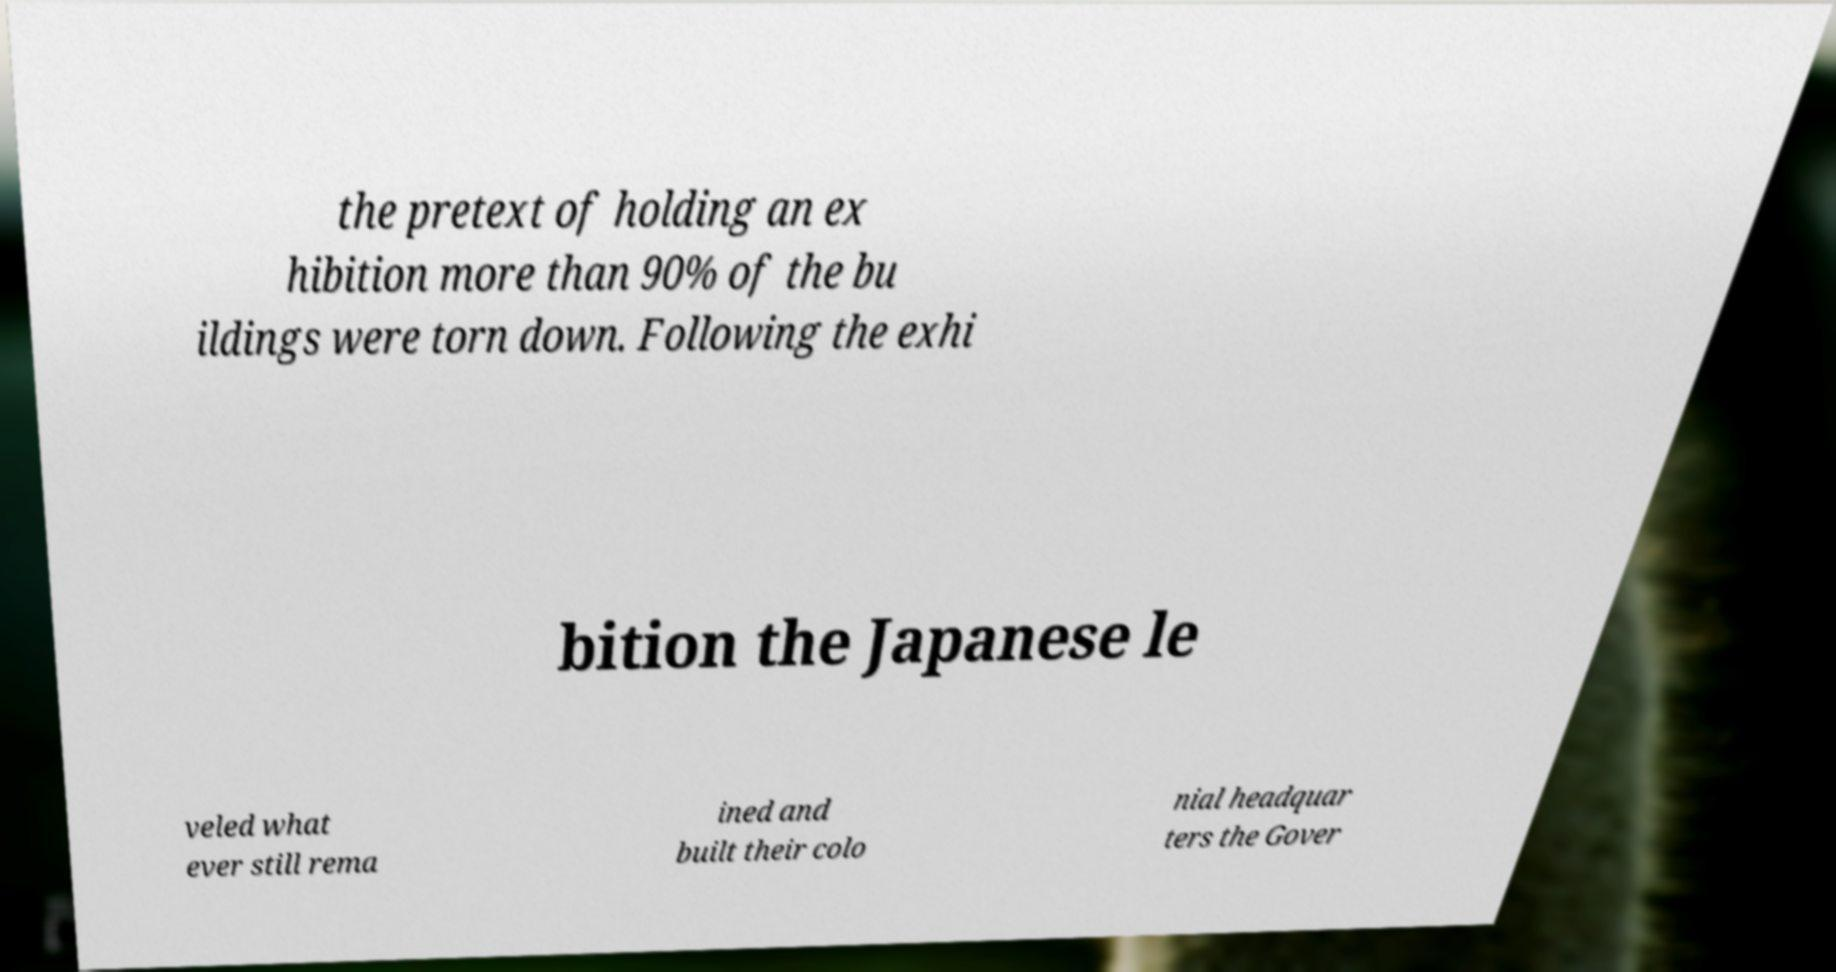Could you assist in decoding the text presented in this image and type it out clearly? the pretext of holding an ex hibition more than 90% of the bu ildings were torn down. Following the exhi bition the Japanese le veled what ever still rema ined and built their colo nial headquar ters the Gover 